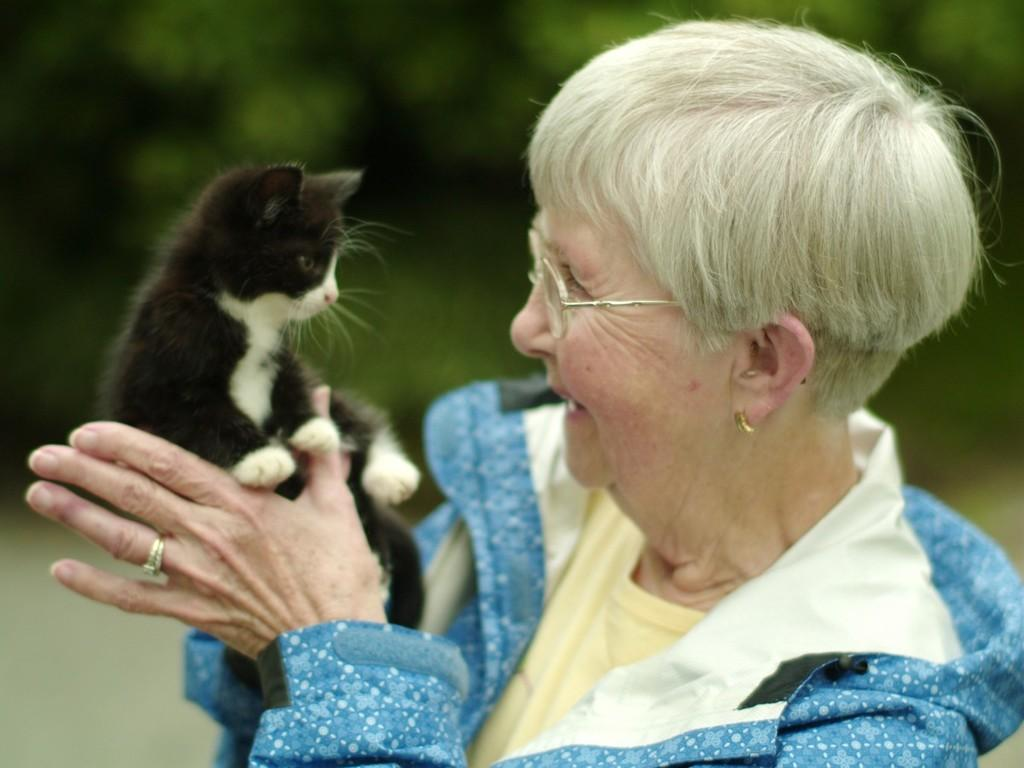Who is the main subject in the image? There is a woman in the image. What is the woman holding in the image? The woman is holding a black cat. Can you describe the background of the image? The background of the image is blurry. What type of match is the woman using to light the celery in the image? There is no match or celery present in the image; it features a woman holding a black cat. 